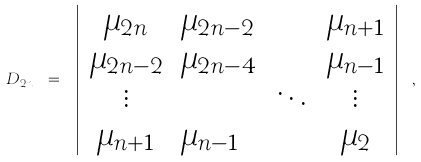Convert formula to latex. <formula><loc_0><loc_0><loc_500><loc_500>D _ { 2 n } \ = \ \left | \begin{array} { c l c c } \mu _ { 2 n } & \mu _ { 2 n - 2 } & \cdots & \mu _ { n + 1 } \\ \mu _ { 2 n - 2 } & \mu _ { 2 n - 4 } & \cdots & \mu _ { n - 1 } \\ \vdots & & \ddots & \vdots \\ \mu _ { n + 1 } & \mu _ { n - 1 } & \cdots & \mu _ { 2 } \end{array} \right | \ ,</formula> 